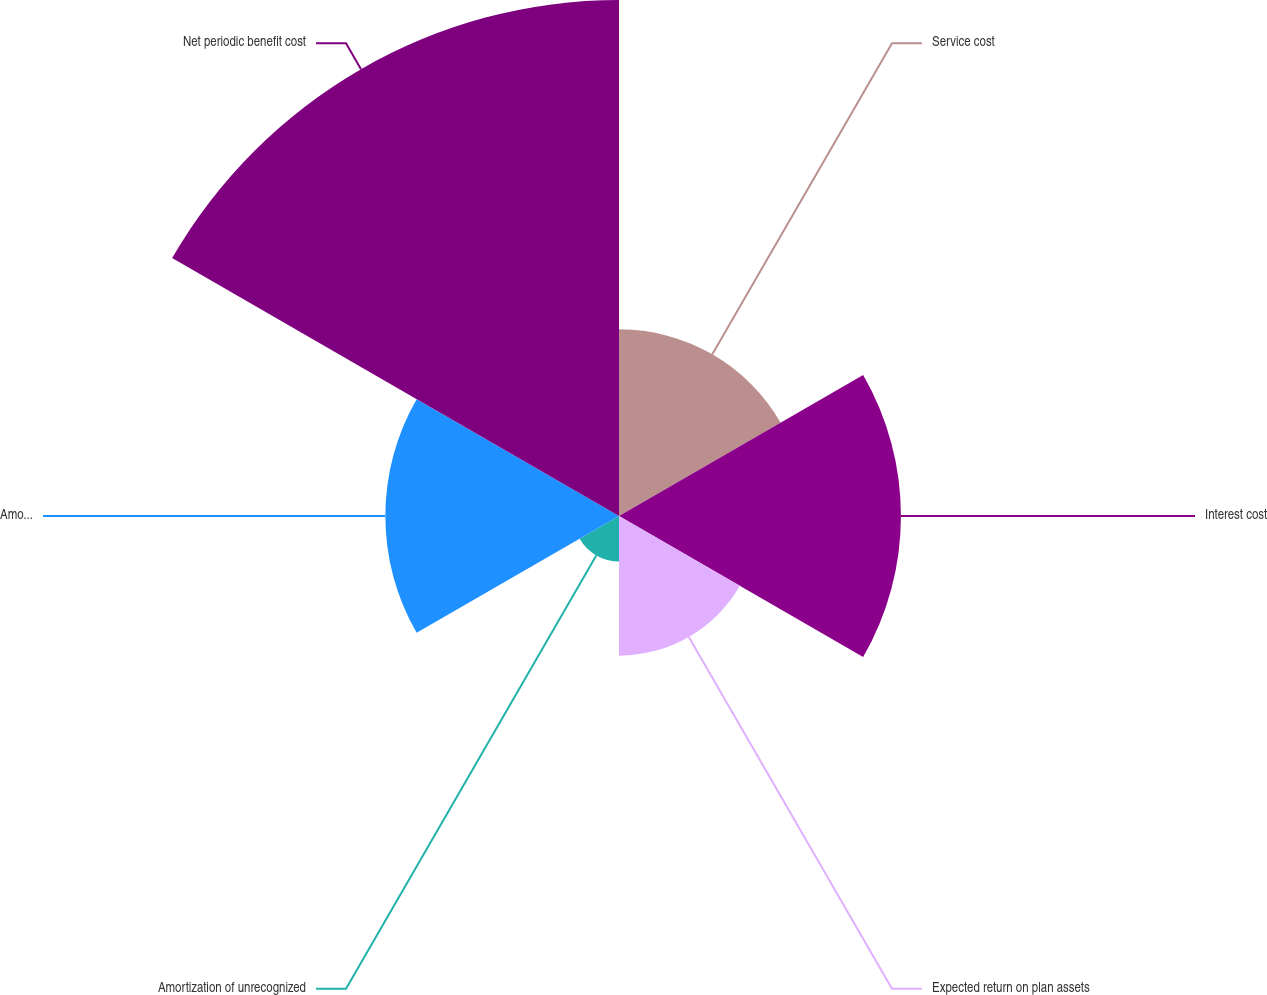Convert chart. <chart><loc_0><loc_0><loc_500><loc_500><pie_chart><fcel>Service cost<fcel>Interest cost<fcel>Expected return on plan assets<fcel>Amortization of unrecognized<fcel>Amortization of net loss<fcel>Net periodic benefit cost<nl><fcel>13.3%<fcel>20.09%<fcel>9.95%<fcel>3.24%<fcel>16.65%<fcel>36.77%<nl></chart> 